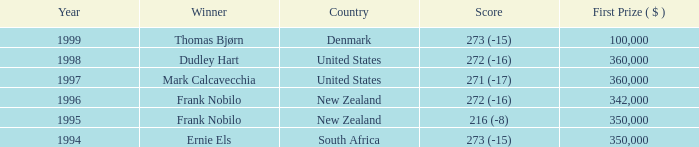What was the aggregate purse in the years after 1996 with a score of 272 (-16) when frank nobilo secured victory? None. 